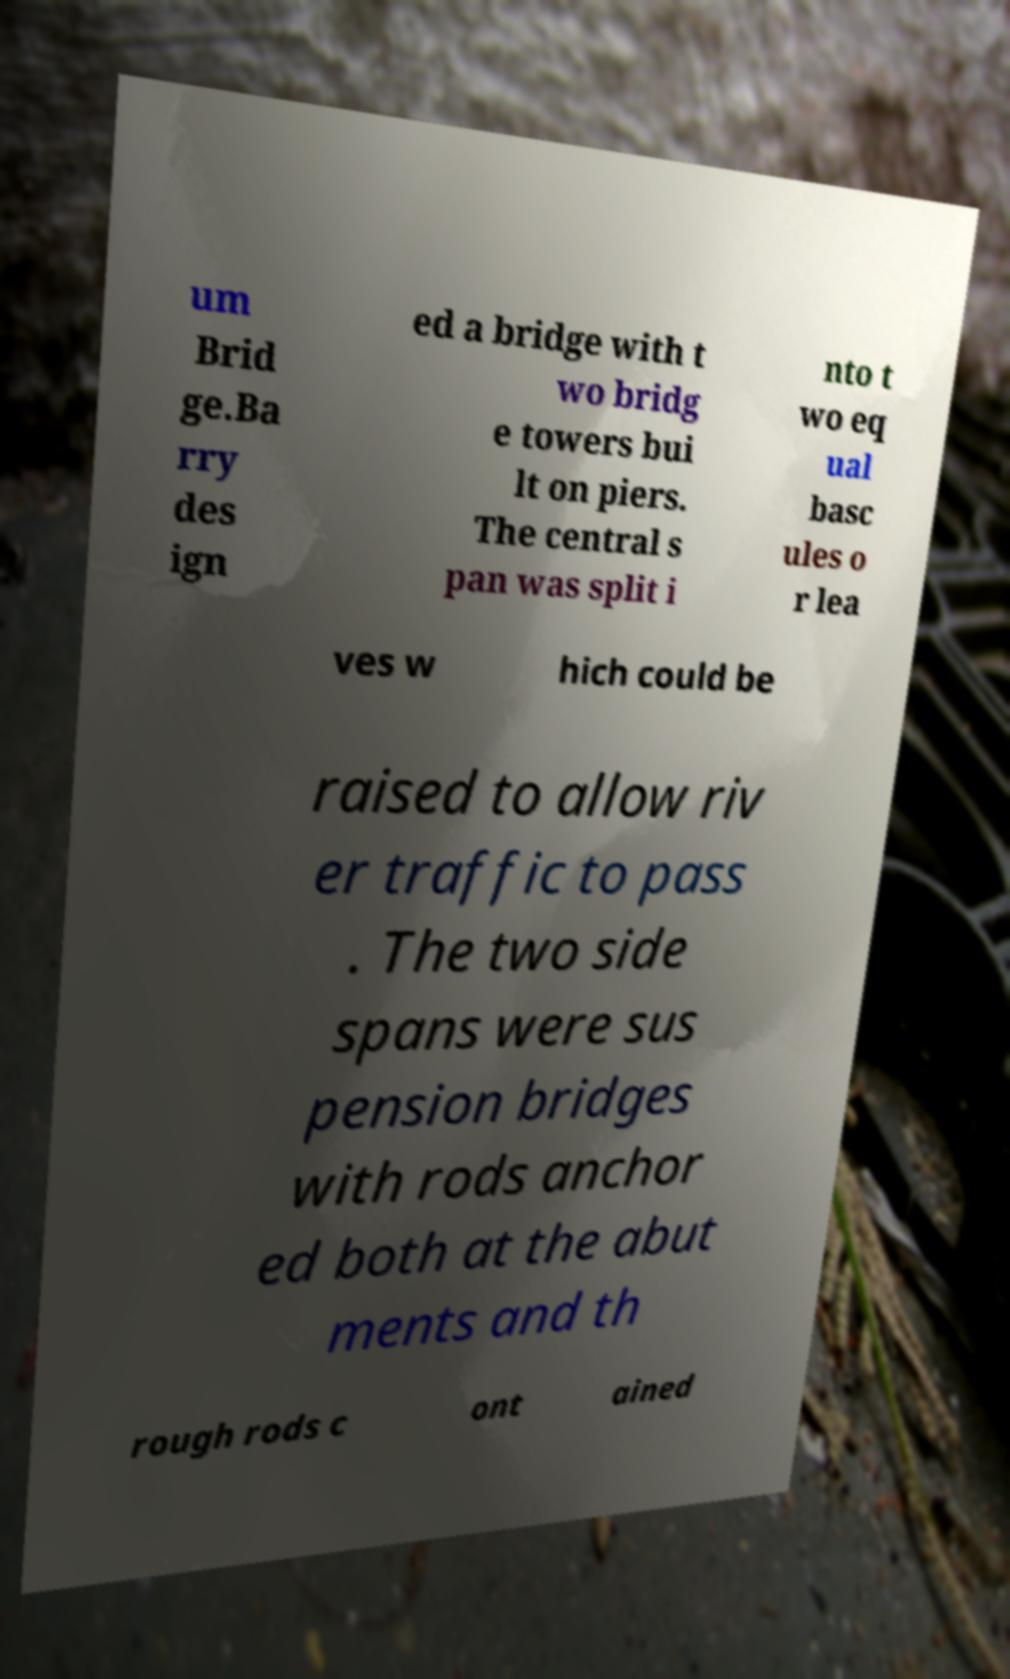What messages or text are displayed in this image? I need them in a readable, typed format. um Brid ge.Ba rry des ign ed a bridge with t wo bridg e towers bui lt on piers. The central s pan was split i nto t wo eq ual basc ules o r lea ves w hich could be raised to allow riv er traffic to pass . The two side spans were sus pension bridges with rods anchor ed both at the abut ments and th rough rods c ont ained 